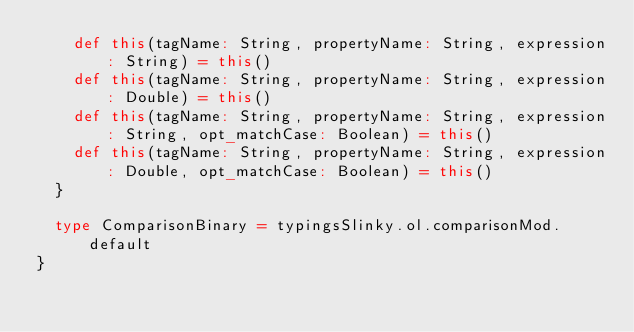Convert code to text. <code><loc_0><loc_0><loc_500><loc_500><_Scala_>    def this(tagName: String, propertyName: String, expression: String) = this()
    def this(tagName: String, propertyName: String, expression: Double) = this()
    def this(tagName: String, propertyName: String, expression: String, opt_matchCase: Boolean) = this()
    def this(tagName: String, propertyName: String, expression: Double, opt_matchCase: Boolean) = this()
  }
  
  type ComparisonBinary = typingsSlinky.ol.comparisonMod.default
}
</code> 